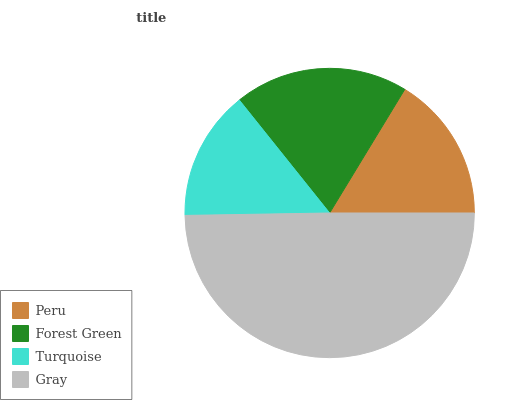Is Turquoise the minimum?
Answer yes or no. Yes. Is Gray the maximum?
Answer yes or no. Yes. Is Forest Green the minimum?
Answer yes or no. No. Is Forest Green the maximum?
Answer yes or no. No. Is Forest Green greater than Peru?
Answer yes or no. Yes. Is Peru less than Forest Green?
Answer yes or no. Yes. Is Peru greater than Forest Green?
Answer yes or no. No. Is Forest Green less than Peru?
Answer yes or no. No. Is Forest Green the high median?
Answer yes or no. Yes. Is Peru the low median?
Answer yes or no. Yes. Is Gray the high median?
Answer yes or no. No. Is Gray the low median?
Answer yes or no. No. 